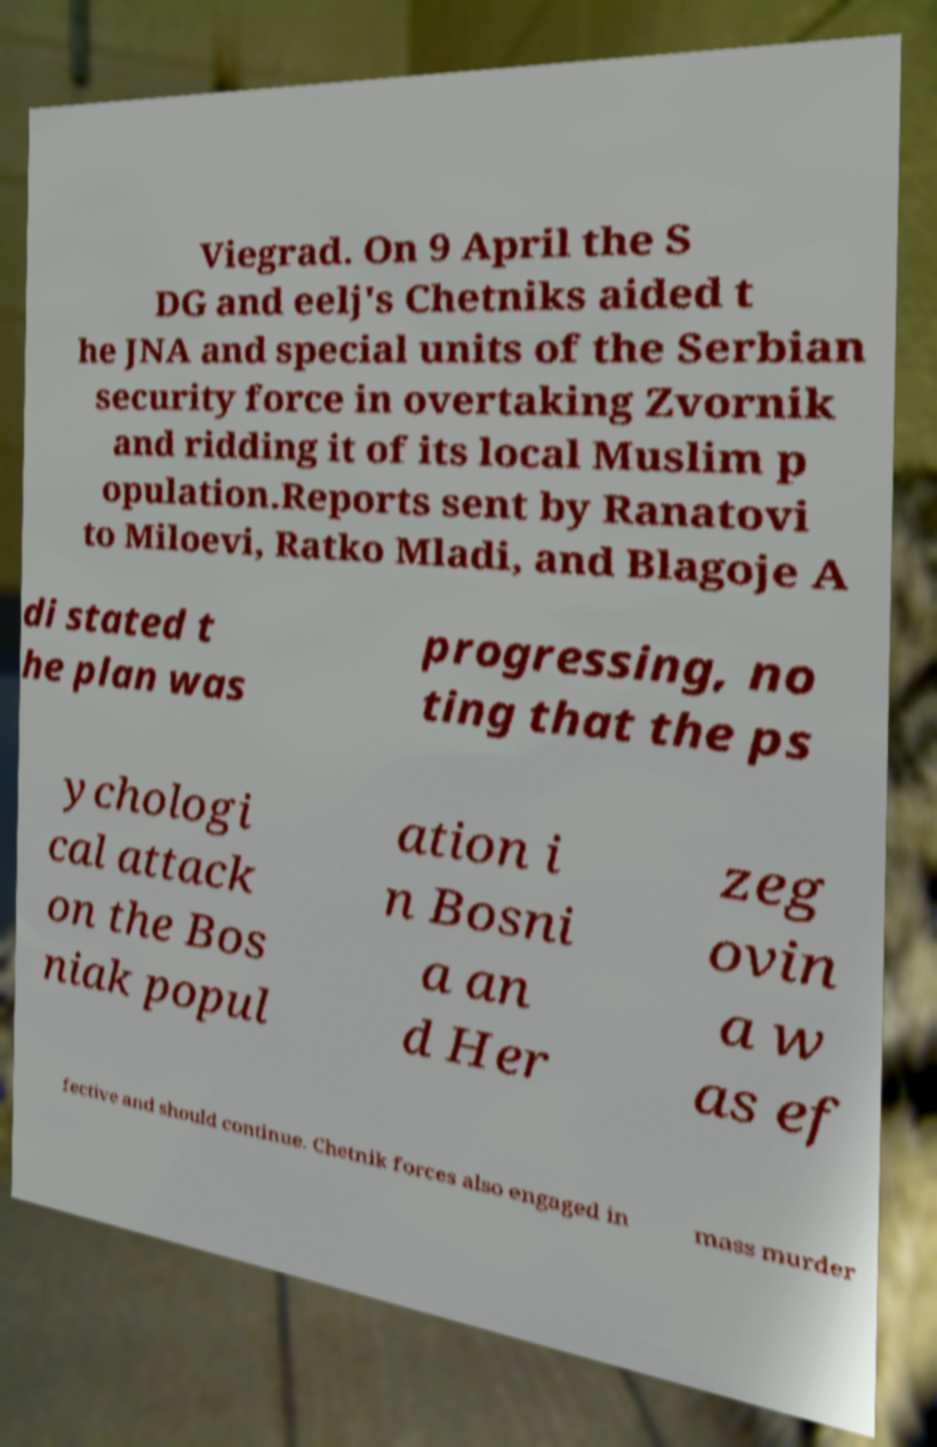Can you read and provide the text displayed in the image?This photo seems to have some interesting text. Can you extract and type it out for me? Viegrad. On 9 April the S DG and eelj's Chetniks aided t he JNA and special units of the Serbian security force in overtaking Zvornik and ridding it of its local Muslim p opulation.Reports sent by Ranatovi to Miloevi, Ratko Mladi, and Blagoje A di stated t he plan was progressing, no ting that the ps ychologi cal attack on the Bos niak popul ation i n Bosni a an d Her zeg ovin a w as ef fective and should continue. Chetnik forces also engaged in mass murder 